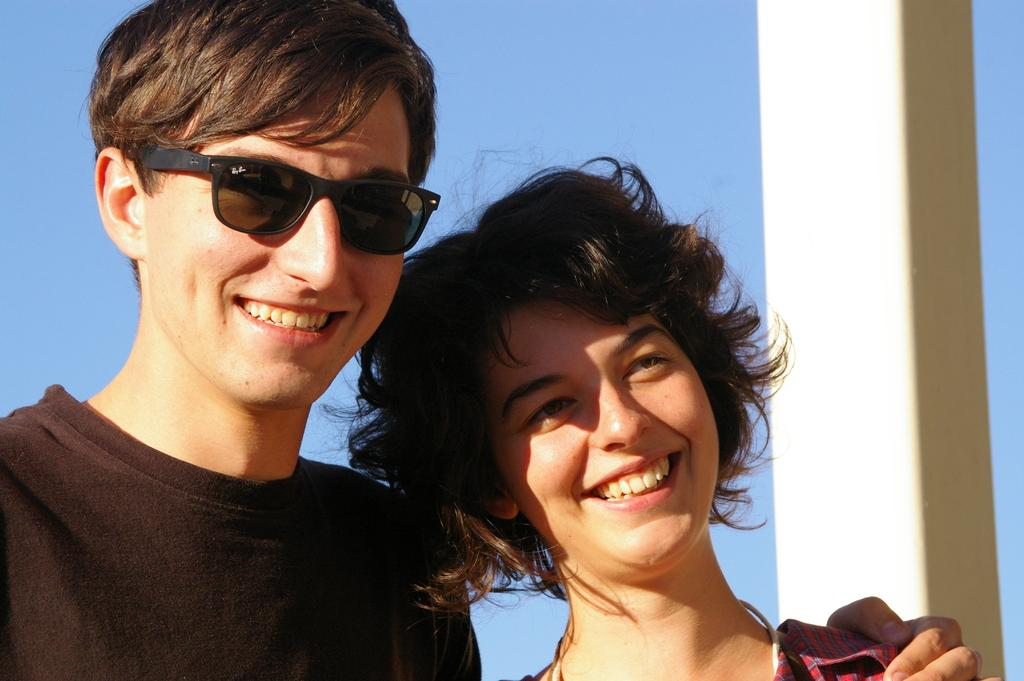What is the gender of the person on the left side of the image? There is a man in the image on the left side. What is the man doing in the image? The man is smiling. What is the man wearing in the image? The man is wearing a t-shirt and spectacles. Can you describe the woman in the image? The woman is also smiling. What is visible at the top of the image? The sky is visible at the top of the image. What type of agreement is being discussed between the man and the woman in the image? There is no indication in the image that the man and the woman are discussing any agreement. Is there a house visible in the image? No, there is no house present in the image. 